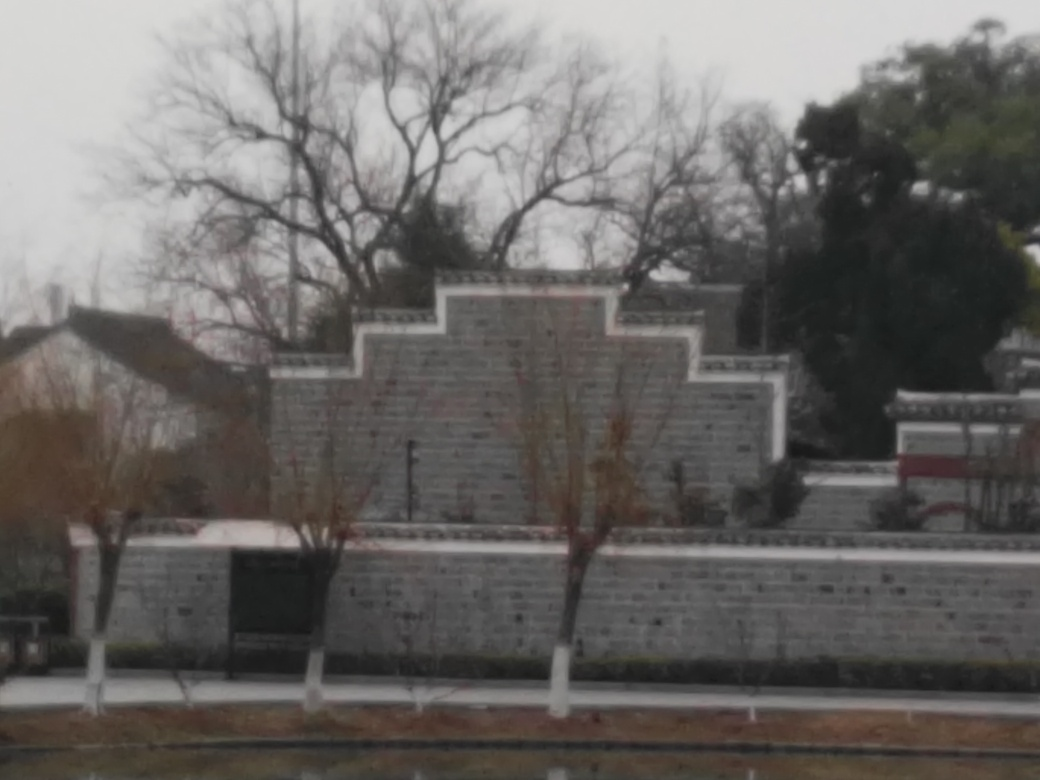Are the colors vivid? From what can be observed, the colors in the image are rather muted, featuring a predominantly grey palette which likely indicates an overcast weather condition or simply the nature of the materials in the structures and surroundings. This creates a somber or subdued atmosphere rather than a vivid scene. 